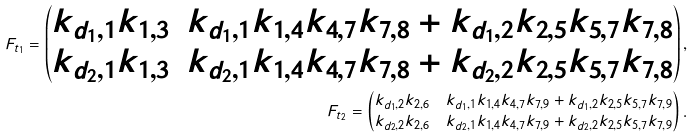<formula> <loc_0><loc_0><loc_500><loc_500>F _ { t _ { 1 } } = \begin{pmatrix} k _ { d _ { 1 } , 1 } k _ { 1 , 3 } & k _ { d _ { 1 } , 1 } k _ { 1 , 4 } k _ { 4 , 7 } k _ { 7 , 8 } + k _ { d _ { 1 } , 2 } k _ { 2 , 5 } k _ { 5 , 7 } k _ { 7 , 8 } \\ k _ { d _ { 2 } , 1 } k _ { 1 , 3 } & k _ { d _ { 2 } , 1 } k _ { 1 , 4 } k _ { 4 , 7 } k _ { 7 , 8 } + k _ { d _ { 2 } , 2 } k _ { 2 , 5 } k _ { 5 , 7 } k _ { 7 , 8 } \end{pmatrix} , \\ F _ { t _ { 2 } } = \begin{pmatrix} k _ { d _ { 1 } , 2 } k _ { 2 , 6 } & k _ { d _ { 1 } , 1 } k _ { 1 , 4 } k _ { 4 , 7 } k _ { 7 , 9 } + k _ { d _ { 1 } , 2 } k _ { 2 , 5 } k _ { 5 , 7 } k _ { 7 , 9 } \\ k _ { d _ { 2 } , 2 } k _ { 2 , 6 } & k _ { d _ { 2 } , 1 } k _ { 1 , 4 } k _ { 4 , 7 } k _ { 7 , 9 } + k _ { d _ { 2 } , 2 } k _ { 2 , 5 } k _ { 5 , 7 } k _ { 7 , 9 } \end{pmatrix} .</formula> 